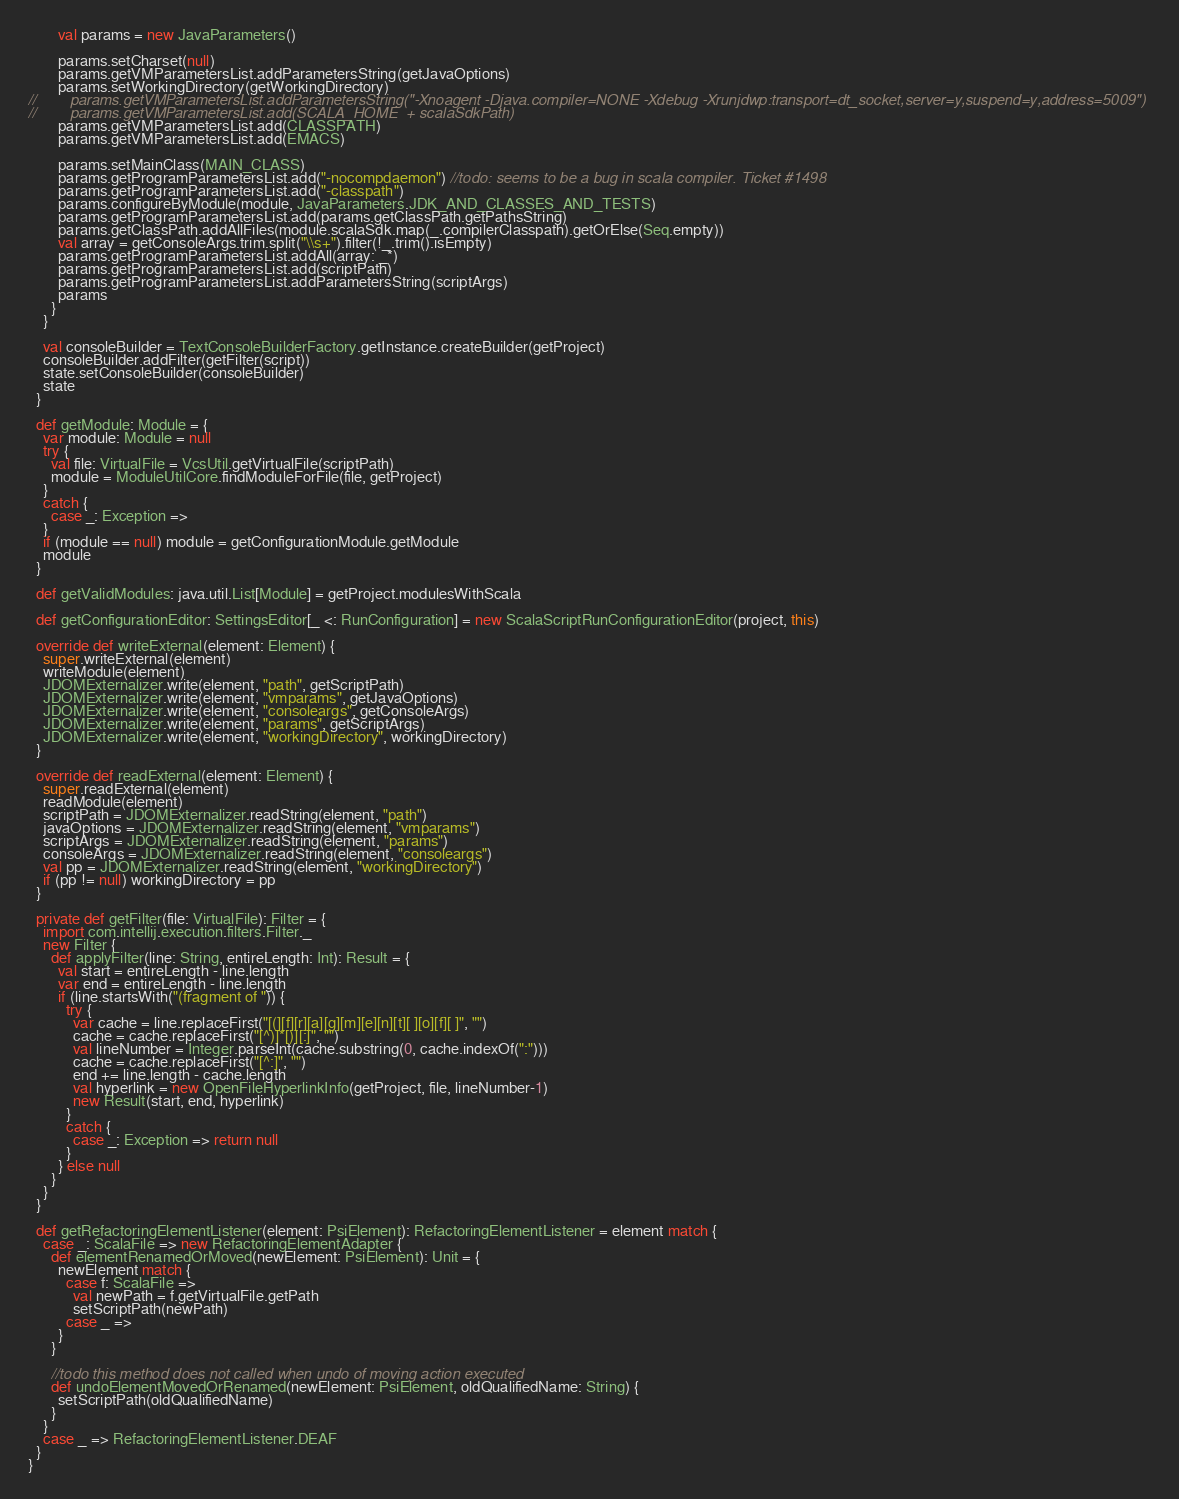<code> <loc_0><loc_0><loc_500><loc_500><_Scala_>        val params = new JavaParameters()

        params.setCharset(null)
        params.getVMParametersList.addParametersString(getJavaOptions)
        params.setWorkingDirectory(getWorkingDirectory)
//        params.getVMParametersList.addParametersString("-Xnoagent -Djava.compiler=NONE -Xdebug -Xrunjdwp:transport=dt_socket,server=y,suspend=y,address=5009")
//        params.getVMParametersList.add(SCALA_HOME  + scalaSdkPath)
        params.getVMParametersList.add(CLASSPATH)
        params.getVMParametersList.add(EMACS)

        params.setMainClass(MAIN_CLASS)
        params.getProgramParametersList.add("-nocompdaemon") //todo: seems to be a bug in scala compiler. Ticket #1498
        params.getProgramParametersList.add("-classpath")
        params.configureByModule(module, JavaParameters.JDK_AND_CLASSES_AND_TESTS)
        params.getProgramParametersList.add(params.getClassPath.getPathsString)
        params.getClassPath.addAllFiles(module.scalaSdk.map(_.compilerClasspath).getOrElse(Seq.empty))
        val array = getConsoleArgs.trim.split("\\s+").filter(!_.trim().isEmpty)
        params.getProgramParametersList.addAll(array: _*)
        params.getProgramParametersList.add(scriptPath)
        params.getProgramParametersList.addParametersString(scriptArgs)
        params
      }
    }

    val consoleBuilder = TextConsoleBuilderFactory.getInstance.createBuilder(getProject)
    consoleBuilder.addFilter(getFilter(script))
    state.setConsoleBuilder(consoleBuilder)
    state
  }

  def getModule: Module = {
    var module: Module = null
    try {
      val file: VirtualFile = VcsUtil.getVirtualFile(scriptPath)
      module = ModuleUtilCore.findModuleForFile(file, getProject)
    }
    catch {
      case _: Exception =>
    }
    if (module == null) module = getConfigurationModule.getModule
    module
  }

  def getValidModules: java.util.List[Module] = getProject.modulesWithScala

  def getConfigurationEditor: SettingsEditor[_ <: RunConfiguration] = new ScalaScriptRunConfigurationEditor(project, this)

  override def writeExternal(element: Element) {
    super.writeExternal(element)
    writeModule(element)
    JDOMExternalizer.write(element, "path", getScriptPath)
    JDOMExternalizer.write(element, "vmparams", getJavaOptions)
    JDOMExternalizer.write(element, "consoleargs", getConsoleArgs)
    JDOMExternalizer.write(element, "params", getScriptArgs)
    JDOMExternalizer.write(element, "workingDirectory", workingDirectory)
  }

  override def readExternal(element: Element) {
    super.readExternal(element)
    readModule(element)
    scriptPath = JDOMExternalizer.readString(element, "path")
    javaOptions = JDOMExternalizer.readString(element, "vmparams")
    scriptArgs = JDOMExternalizer.readString(element, "params")
    consoleArgs = JDOMExternalizer.readString(element, "consoleargs")
    val pp = JDOMExternalizer.readString(element, "workingDirectory")
    if (pp != null) workingDirectory = pp
  }

  private def getFilter(file: VirtualFile): Filter = {
    import com.intellij.execution.filters.Filter._
    new Filter {
      def applyFilter(line: String, entireLength: Int): Result = {
        val start = entireLength - line.length
        var end = entireLength - line.length
        if (line.startsWith("(fragment of ")) {
          try {
            var cache = line.replaceFirst("[(][f][r][a][g][m][e][n][t][ ][o][f][ ]", "")
            cache = cache.replaceFirst("[^)]*[)][:]", "")
            val lineNumber = Integer.parseInt(cache.substring(0, cache.indexOf(":")))
            cache = cache.replaceFirst("[^:]", "")
            end += line.length - cache.length
            val hyperlink = new OpenFileHyperlinkInfo(getProject, file, lineNumber-1)
            new Result(start, end, hyperlink)
          }
          catch {
            case _: Exception => return null
          }
        } else null
      }
    }
  }

  def getRefactoringElementListener(element: PsiElement): RefactoringElementListener = element match {
    case _: ScalaFile => new RefactoringElementAdapter {
      def elementRenamedOrMoved(newElement: PsiElement): Unit = {
        newElement match {
          case f: ScalaFile =>
            val newPath = f.getVirtualFile.getPath
            setScriptPath(newPath)
          case _ =>
        }
      }

      //todo this method does not called when undo of moving action executed
      def undoElementMovedOrRenamed(newElement: PsiElement, oldQualifiedName: String) {
        setScriptPath(oldQualifiedName)
      }
    }
    case _ => RefactoringElementListener.DEAF
  }
}
</code> 